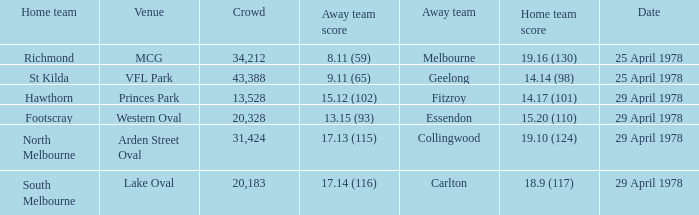What was the away team that played at Princes Park? Fitzroy. 